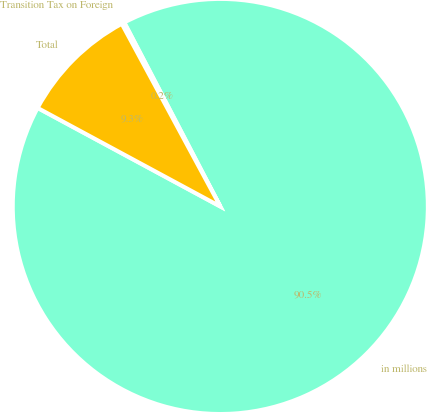Convert chart to OTSL. <chart><loc_0><loc_0><loc_500><loc_500><pie_chart><fcel>in millions<fcel>Transition Tax on Foreign<fcel>Total<nl><fcel>90.52%<fcel>0.22%<fcel>9.25%<nl></chart> 